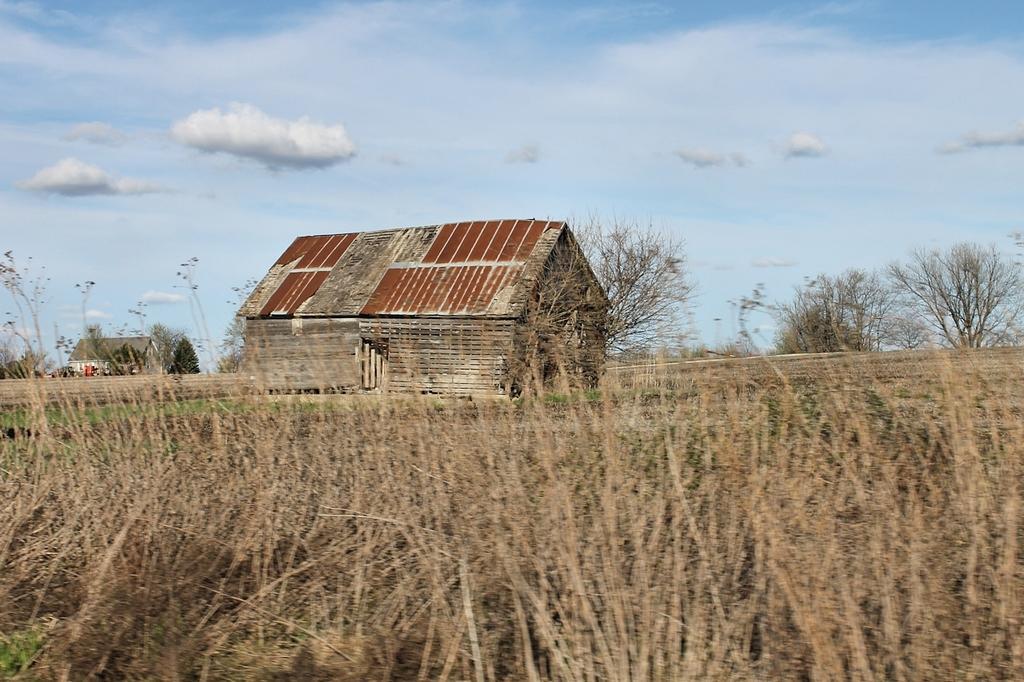Describe this image in one or two sentences. This is the picture of a place where we have two sheds and around there are some trees, plants around. 